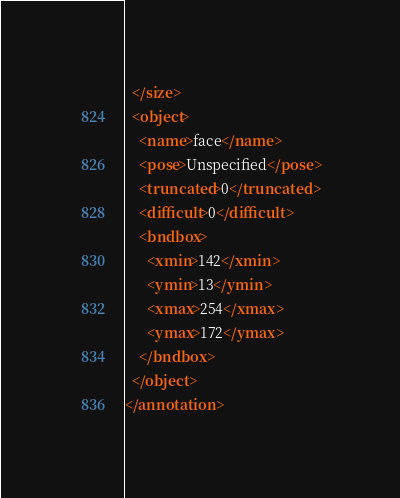Convert code to text. <code><loc_0><loc_0><loc_500><loc_500><_XML_>  </size>
  <object>
    <name>face</name>
    <pose>Unspecified</pose>
    <truncated>0</truncated>
    <difficult>0</difficult>
    <bndbox>
      <xmin>142</xmin>
      <ymin>13</ymin>
      <xmax>254</xmax>
      <ymax>172</ymax>
    </bndbox>
  </object>
</annotation>
</code> 